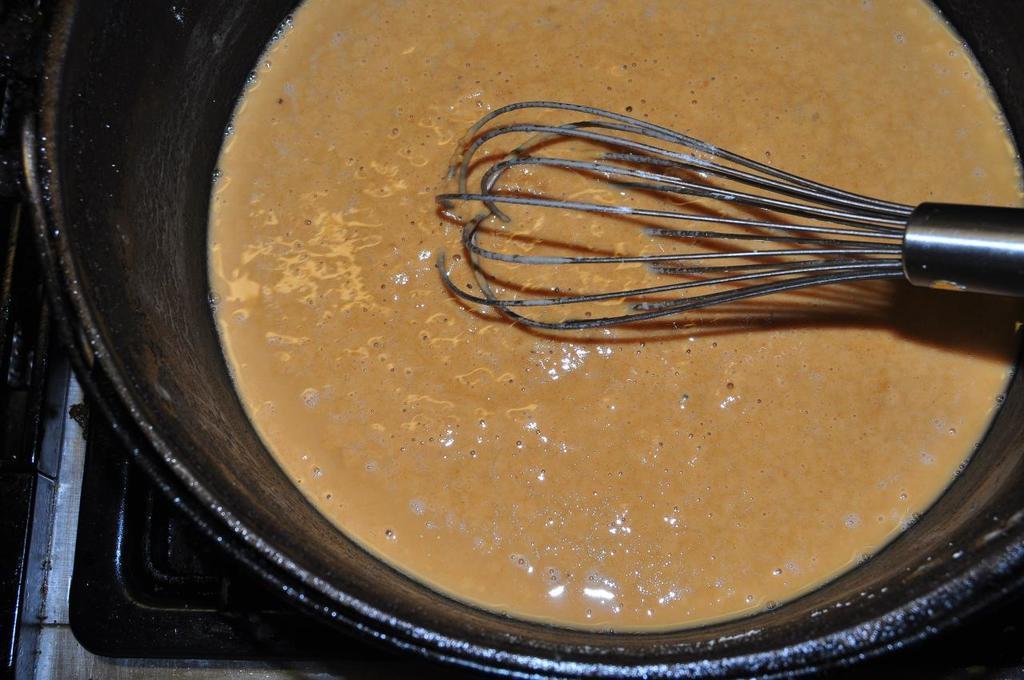In one or two sentences, can you explain what this image depicts? In this image there is some liquid in the bowl and some stirrer. 